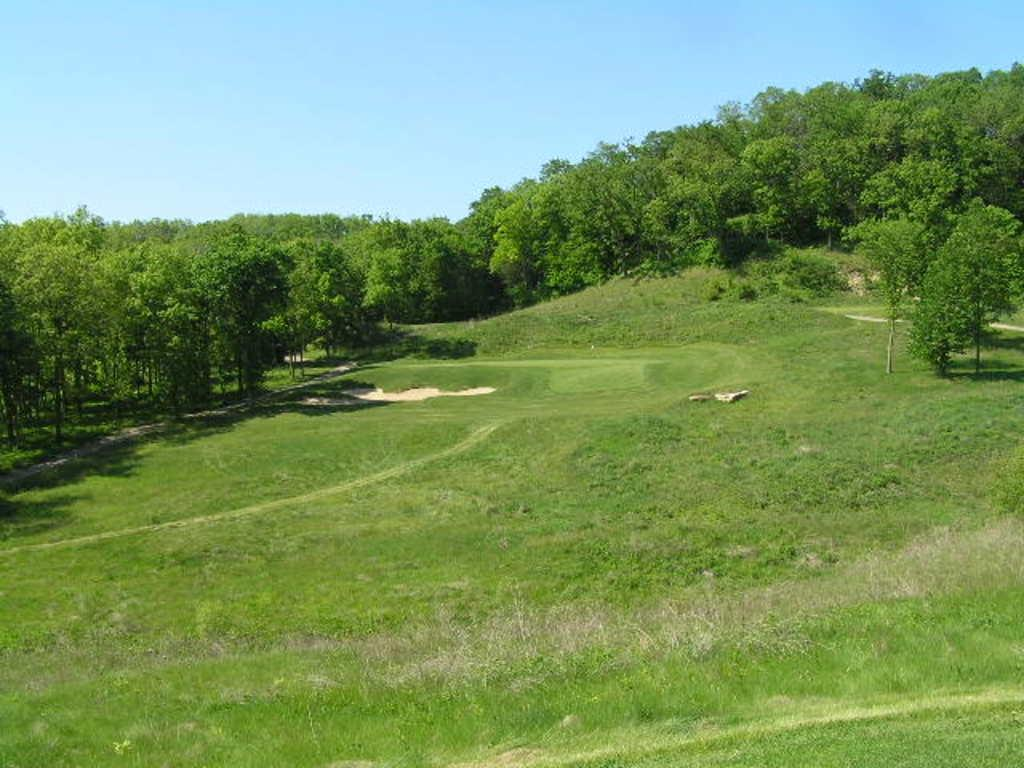What can be seen in the sky in the image? The sky is visible in the image. What type of vegetation is present in the image? There are trees and shrubs visible in the image. What is the ground made of in the image? The ground is visible in the image, and it contains sand. Are there any other natural elements present in the image? Yes, rocks are visible in the image. What type of wool is being used to create the tree in the image? There is no wool present in the image, and the trees are natural vegetation. What type of drink is being served in the image? There is no drink present in the image; it primarily features natural elements such as the sky, trees, ground, sand, shrubs, and rocks. 